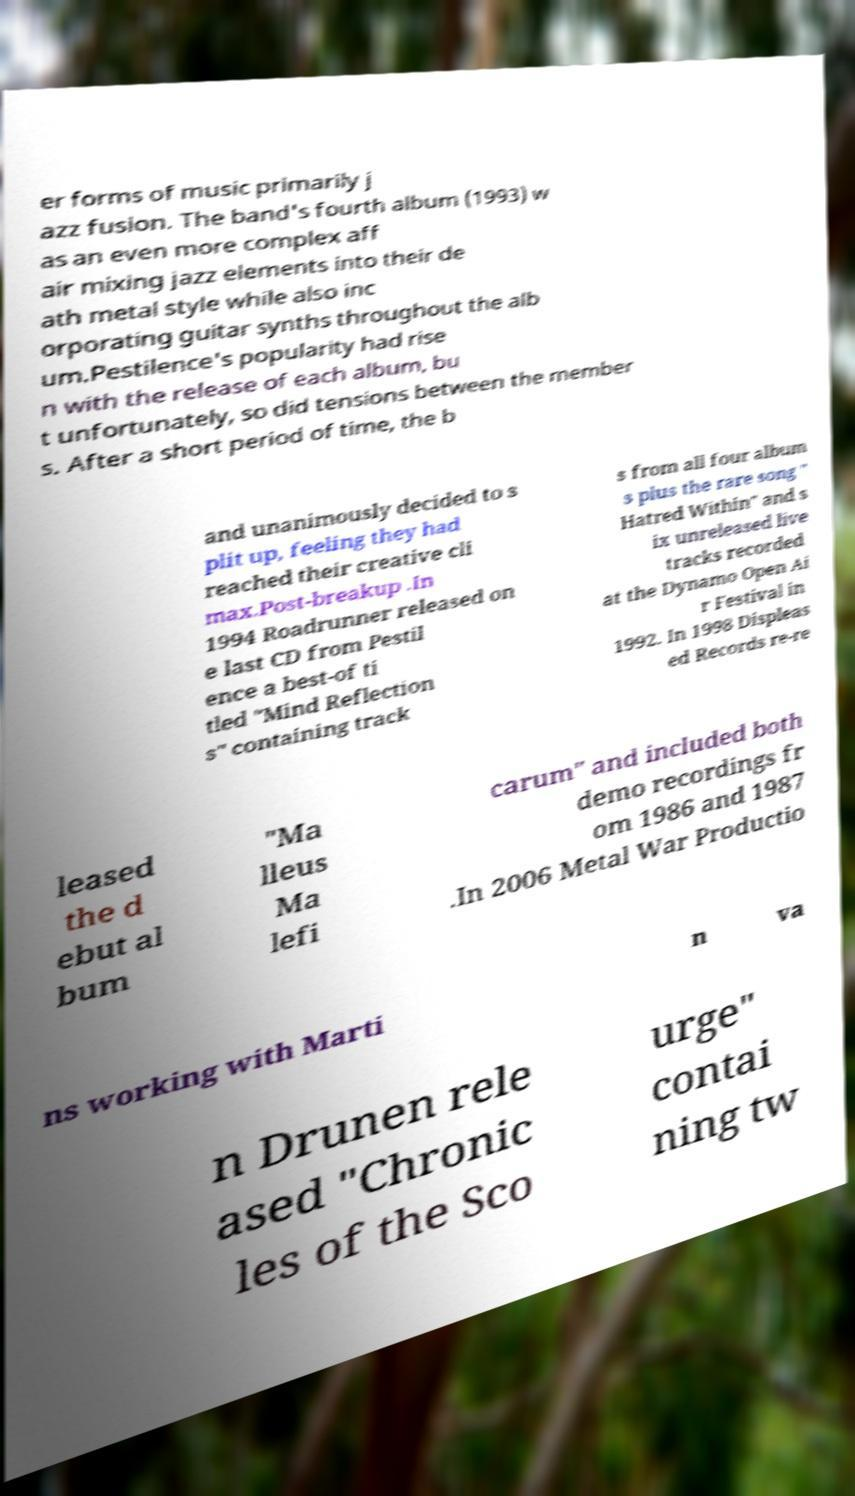Please identify and transcribe the text found in this image. er forms of music primarily j azz fusion. The band's fourth album (1993) w as an even more complex aff air mixing jazz elements into their de ath metal style while also inc orporating guitar synths throughout the alb um.Pestilence's popularity had rise n with the release of each album, bu t unfortunately, so did tensions between the member s. After a short period of time, the b and unanimously decided to s plit up, feeling they had reached their creative cli max.Post-breakup .In 1994 Roadrunner released on e last CD from Pestil ence a best-of ti tled "Mind Reflection s" containing track s from all four album s plus the rare song " Hatred Within" and s ix unreleased live tracks recorded at the Dynamo Open Ai r Festival in 1992. In 1998 Displeas ed Records re-re leased the d ebut al bum "Ma lleus Ma lefi carum" and included both demo recordings fr om 1986 and 1987 .In 2006 Metal War Productio ns working with Marti n va n Drunen rele ased "Chronic les of the Sco urge" contai ning tw 